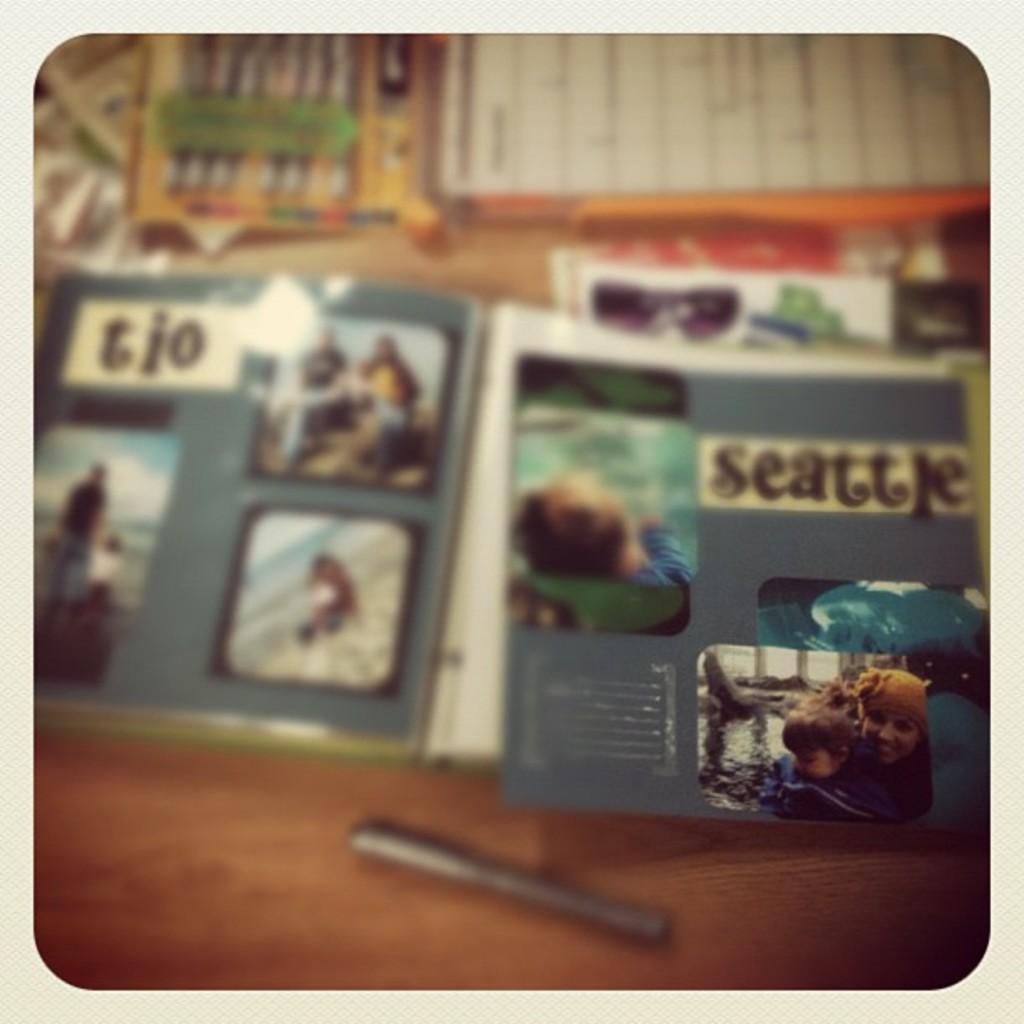How would you summarize this image in a sentence or two? There are books and papers. On that there are images. On the right side there is an image with a person and a baby. Also there is water. And there is a pen on the surface. And the image is blurred. 